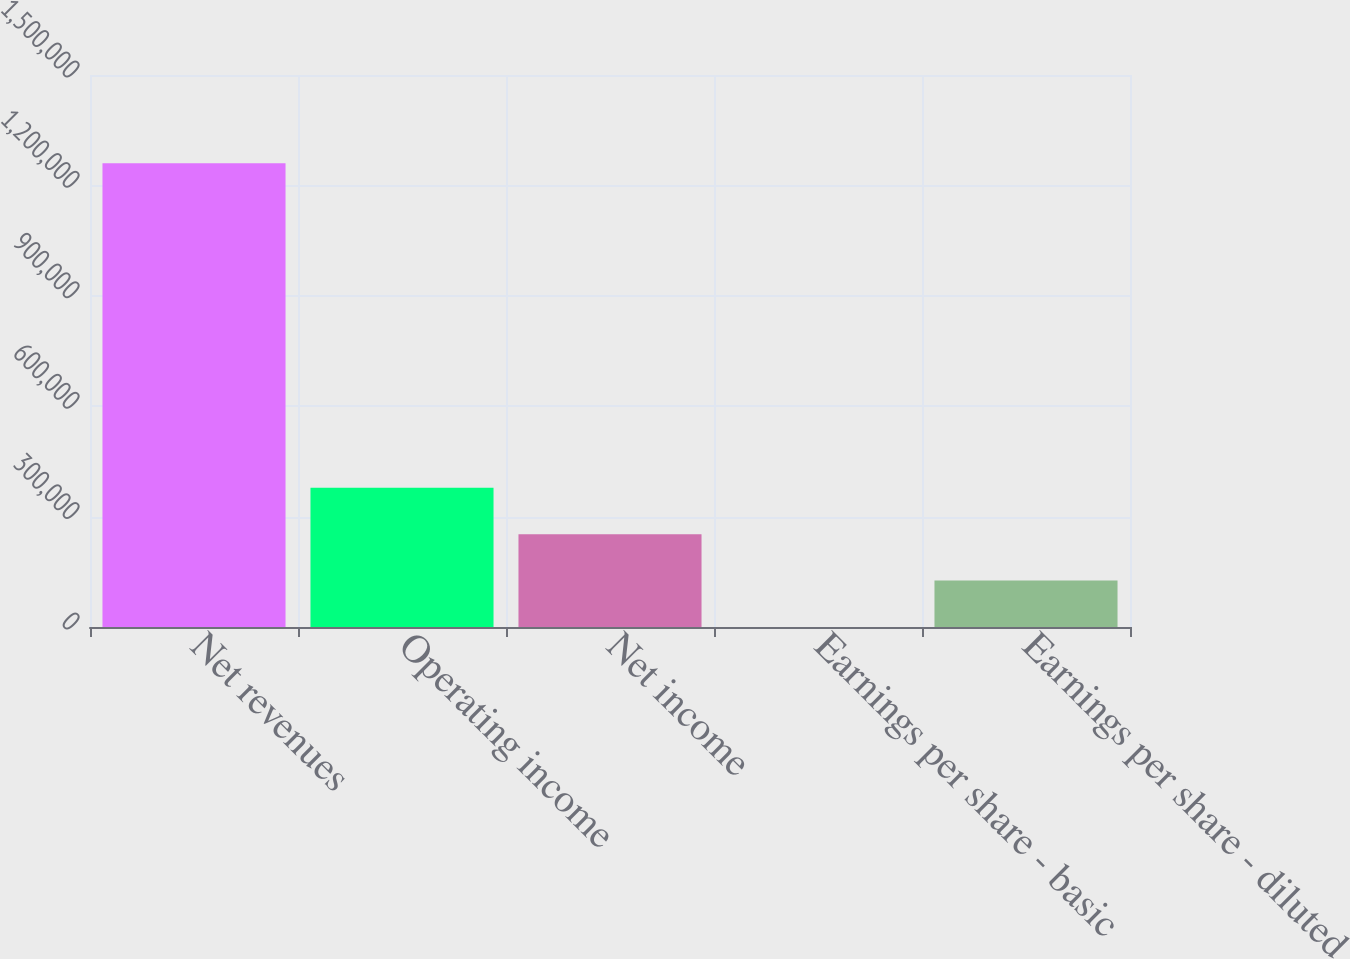Convert chart. <chart><loc_0><loc_0><loc_500><loc_500><bar_chart><fcel>Net revenues<fcel>Operating income<fcel>Net income<fcel>Earnings per share - basic<fcel>Earnings per share - diluted<nl><fcel>1.26041e+06<fcel>378122<fcel>252082<fcel>0.13<fcel>126041<nl></chart> 